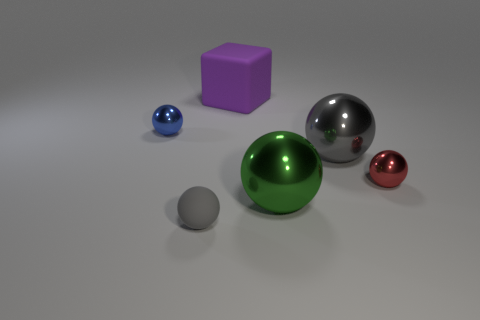Subtract all large green spheres. How many spheres are left? 4 Subtract 2 balls. How many balls are left? 3 Add 3 tiny cyan matte blocks. How many objects exist? 9 Subtract all blue balls. How many balls are left? 4 Subtract all spheres. How many objects are left? 1 Subtract all yellow cubes. Subtract all red spheres. How many cubes are left? 1 Subtract all brown cubes. How many red spheres are left? 1 Subtract all cyan matte blocks. Subtract all gray matte spheres. How many objects are left? 5 Add 2 small red things. How many small red things are left? 3 Add 4 large things. How many large things exist? 7 